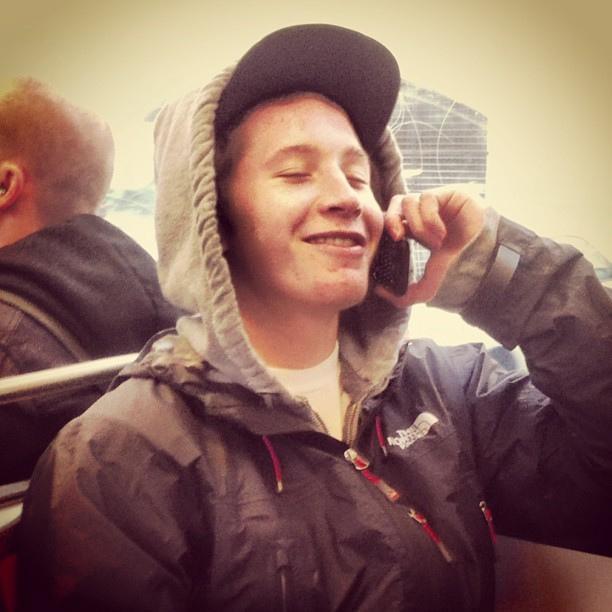How many people are there?
Give a very brief answer. 2. How many pizza slices are missing from the tray?
Give a very brief answer. 0. 